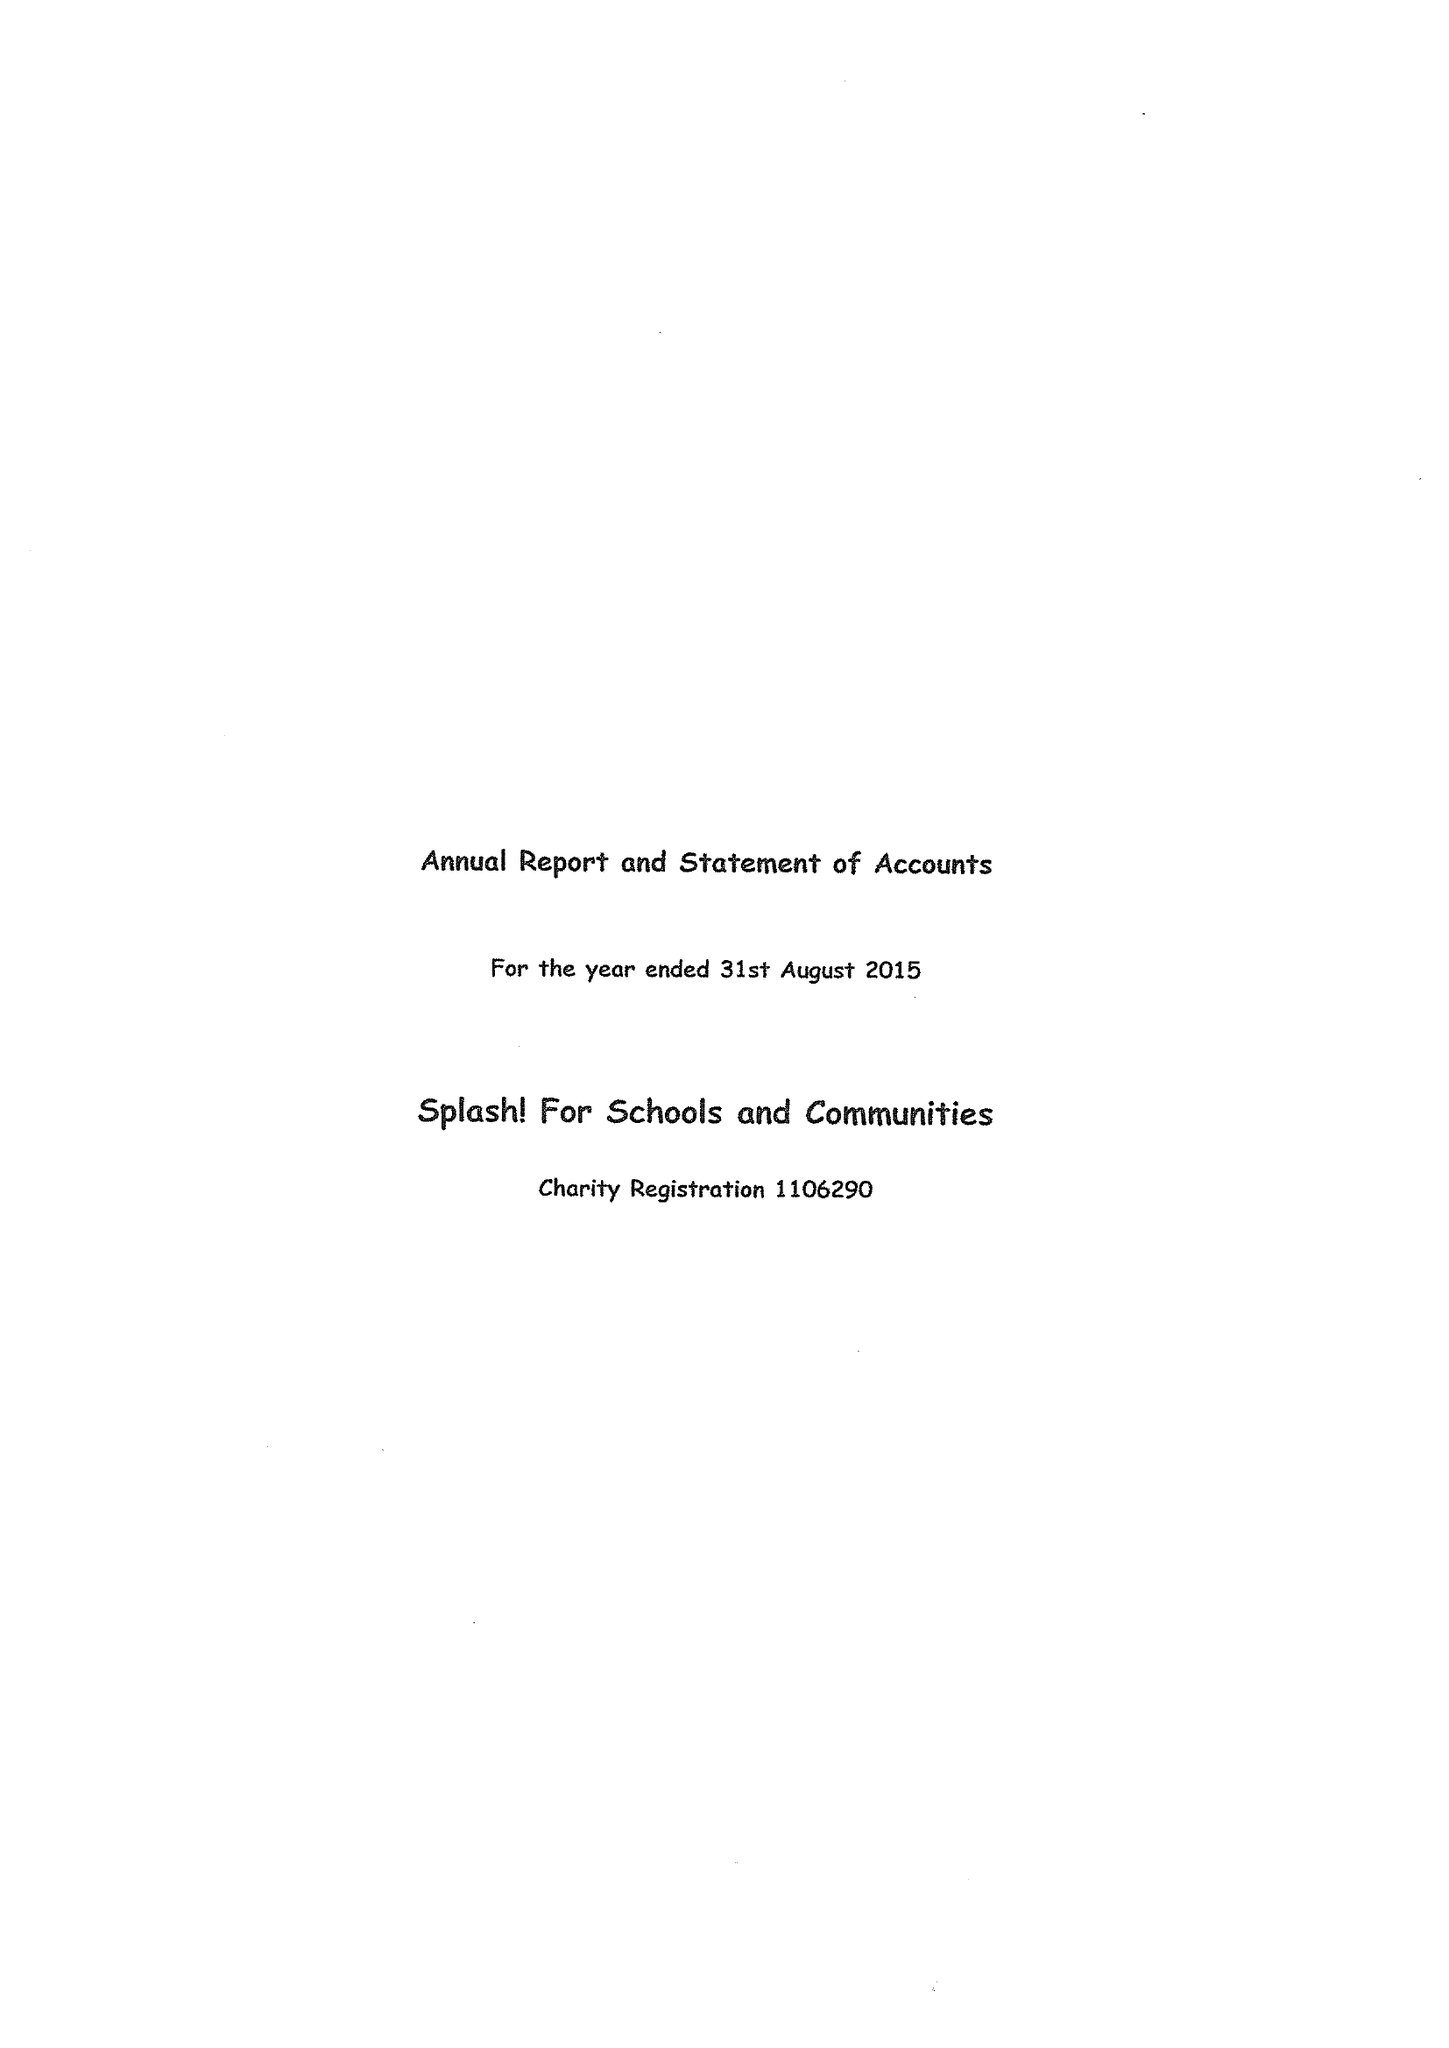What is the value for the address__post_town?
Answer the question using a single word or phrase. None 